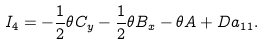<formula> <loc_0><loc_0><loc_500><loc_500>I _ { 4 } = - \frac { 1 } { 2 } \theta C _ { y } - \frac { 1 } { 2 } \theta B _ { x } - \theta A + D a _ { 1 1 } .</formula> 